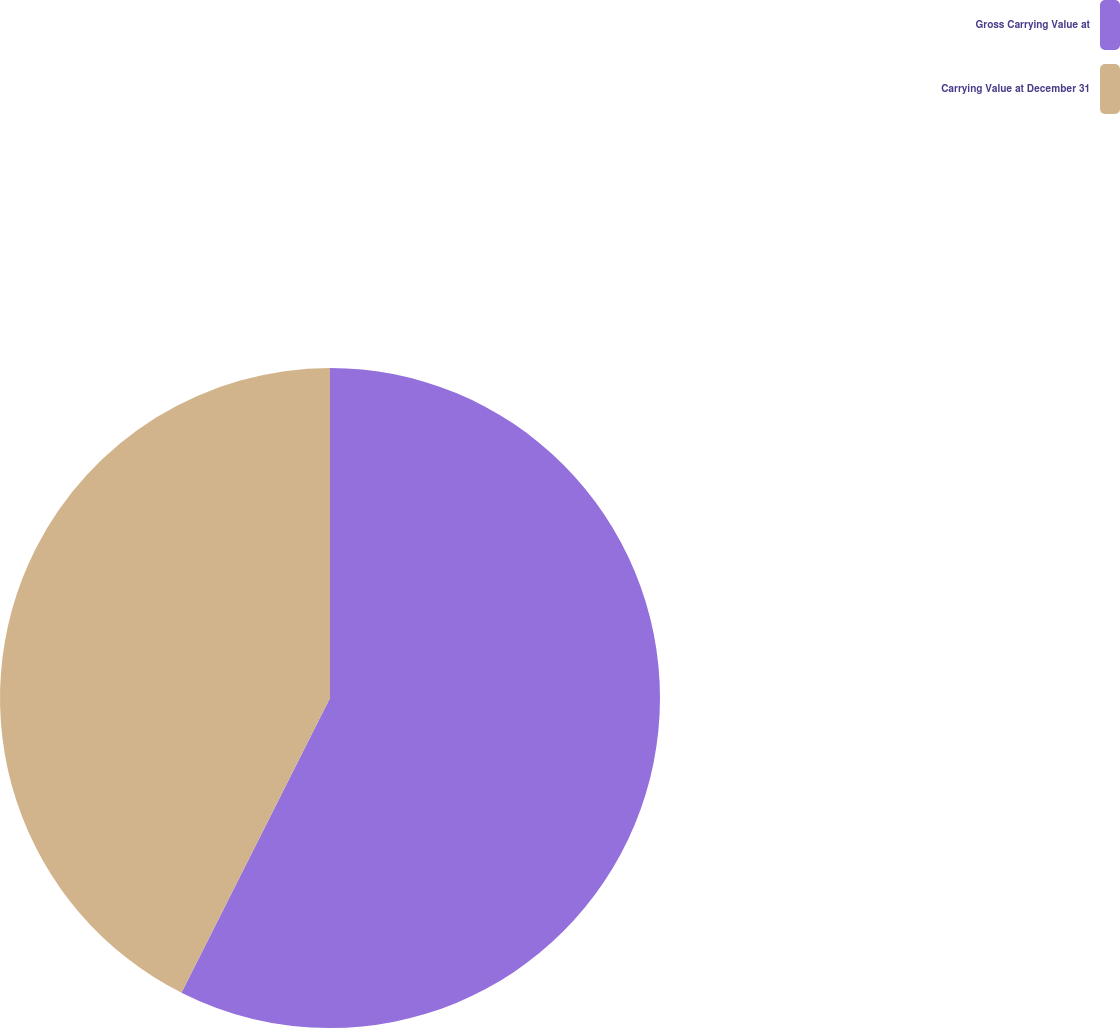Convert chart to OTSL. <chart><loc_0><loc_0><loc_500><loc_500><pie_chart><fcel>Gross Carrying Value at<fcel>Carrying Value at December 31<nl><fcel>57.43%<fcel>42.57%<nl></chart> 